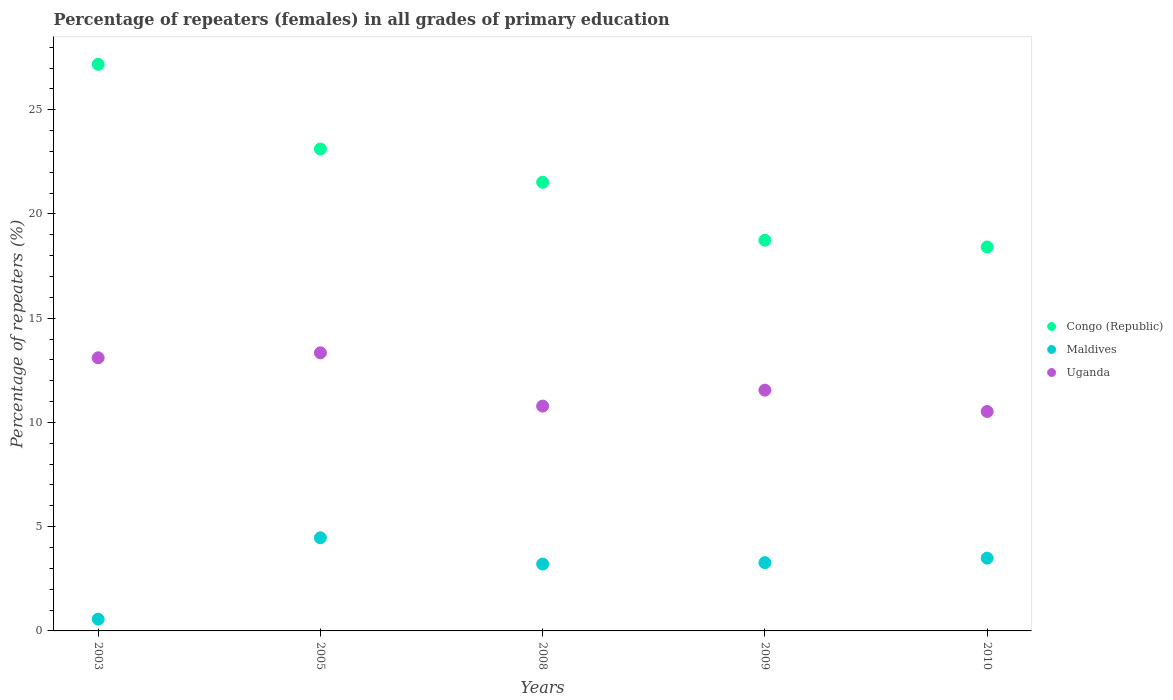How many different coloured dotlines are there?
Ensure brevity in your answer.  3. Is the number of dotlines equal to the number of legend labels?
Offer a very short reply. Yes. What is the percentage of repeaters (females) in Maldives in 2008?
Give a very brief answer. 3.21. Across all years, what is the maximum percentage of repeaters (females) in Uganda?
Provide a short and direct response. 13.34. Across all years, what is the minimum percentage of repeaters (females) in Maldives?
Provide a succinct answer. 0.56. In which year was the percentage of repeaters (females) in Congo (Republic) maximum?
Provide a succinct answer. 2003. What is the total percentage of repeaters (females) in Maldives in the graph?
Ensure brevity in your answer.  15. What is the difference between the percentage of repeaters (females) in Maldives in 2003 and that in 2010?
Ensure brevity in your answer.  -2.93. What is the difference between the percentage of repeaters (females) in Congo (Republic) in 2010 and the percentage of repeaters (females) in Maldives in 2009?
Make the answer very short. 15.14. What is the average percentage of repeaters (females) in Uganda per year?
Your answer should be very brief. 11.86. In the year 2009, what is the difference between the percentage of repeaters (females) in Uganda and percentage of repeaters (females) in Maldives?
Keep it short and to the point. 8.27. In how many years, is the percentage of repeaters (females) in Congo (Republic) greater than 22 %?
Your response must be concise. 2. What is the ratio of the percentage of repeaters (females) in Maldives in 2005 to that in 2008?
Ensure brevity in your answer.  1.39. Is the percentage of repeaters (females) in Uganda in 2009 less than that in 2010?
Keep it short and to the point. No. Is the difference between the percentage of repeaters (females) in Uganda in 2003 and 2009 greater than the difference between the percentage of repeaters (females) in Maldives in 2003 and 2009?
Make the answer very short. Yes. What is the difference between the highest and the second highest percentage of repeaters (females) in Uganda?
Ensure brevity in your answer.  0.24. What is the difference between the highest and the lowest percentage of repeaters (females) in Maldives?
Offer a terse response. 3.9. How many dotlines are there?
Your answer should be compact. 3. Does the graph contain grids?
Offer a terse response. No. Where does the legend appear in the graph?
Provide a short and direct response. Center right. What is the title of the graph?
Keep it short and to the point. Percentage of repeaters (females) in all grades of primary education. What is the label or title of the X-axis?
Make the answer very short. Years. What is the label or title of the Y-axis?
Your answer should be compact. Percentage of repeaters (%). What is the Percentage of repeaters (%) of Congo (Republic) in 2003?
Offer a very short reply. 27.18. What is the Percentage of repeaters (%) of Maldives in 2003?
Offer a very short reply. 0.56. What is the Percentage of repeaters (%) of Uganda in 2003?
Make the answer very short. 13.1. What is the Percentage of repeaters (%) in Congo (Republic) in 2005?
Ensure brevity in your answer.  23.12. What is the Percentage of repeaters (%) of Maldives in 2005?
Provide a succinct answer. 4.47. What is the Percentage of repeaters (%) of Uganda in 2005?
Provide a succinct answer. 13.34. What is the Percentage of repeaters (%) of Congo (Republic) in 2008?
Provide a succinct answer. 21.52. What is the Percentage of repeaters (%) of Maldives in 2008?
Your response must be concise. 3.21. What is the Percentage of repeaters (%) of Uganda in 2008?
Provide a succinct answer. 10.78. What is the Percentage of repeaters (%) of Congo (Republic) in 2009?
Give a very brief answer. 18.74. What is the Percentage of repeaters (%) of Maldives in 2009?
Offer a terse response. 3.27. What is the Percentage of repeaters (%) in Uganda in 2009?
Provide a succinct answer. 11.55. What is the Percentage of repeaters (%) of Congo (Republic) in 2010?
Provide a succinct answer. 18.42. What is the Percentage of repeaters (%) of Maldives in 2010?
Ensure brevity in your answer.  3.49. What is the Percentage of repeaters (%) in Uganda in 2010?
Offer a terse response. 10.53. Across all years, what is the maximum Percentage of repeaters (%) of Congo (Republic)?
Provide a succinct answer. 27.18. Across all years, what is the maximum Percentage of repeaters (%) in Maldives?
Offer a very short reply. 4.47. Across all years, what is the maximum Percentage of repeaters (%) in Uganda?
Keep it short and to the point. 13.34. Across all years, what is the minimum Percentage of repeaters (%) in Congo (Republic)?
Your response must be concise. 18.42. Across all years, what is the minimum Percentage of repeaters (%) in Maldives?
Make the answer very short. 0.56. Across all years, what is the minimum Percentage of repeaters (%) in Uganda?
Make the answer very short. 10.53. What is the total Percentage of repeaters (%) in Congo (Republic) in the graph?
Your answer should be compact. 108.98. What is the total Percentage of repeaters (%) in Maldives in the graph?
Offer a very short reply. 15. What is the total Percentage of repeaters (%) of Uganda in the graph?
Make the answer very short. 59.3. What is the difference between the Percentage of repeaters (%) in Congo (Republic) in 2003 and that in 2005?
Make the answer very short. 4.06. What is the difference between the Percentage of repeaters (%) in Maldives in 2003 and that in 2005?
Give a very brief answer. -3.9. What is the difference between the Percentage of repeaters (%) in Uganda in 2003 and that in 2005?
Offer a terse response. -0.24. What is the difference between the Percentage of repeaters (%) in Congo (Republic) in 2003 and that in 2008?
Your answer should be compact. 5.66. What is the difference between the Percentage of repeaters (%) of Maldives in 2003 and that in 2008?
Provide a succinct answer. -2.64. What is the difference between the Percentage of repeaters (%) in Uganda in 2003 and that in 2008?
Offer a terse response. 2.32. What is the difference between the Percentage of repeaters (%) of Congo (Republic) in 2003 and that in 2009?
Ensure brevity in your answer.  8.44. What is the difference between the Percentage of repeaters (%) in Maldives in 2003 and that in 2009?
Offer a terse response. -2.71. What is the difference between the Percentage of repeaters (%) of Uganda in 2003 and that in 2009?
Give a very brief answer. 1.55. What is the difference between the Percentage of repeaters (%) in Congo (Republic) in 2003 and that in 2010?
Provide a succinct answer. 8.76. What is the difference between the Percentage of repeaters (%) of Maldives in 2003 and that in 2010?
Keep it short and to the point. -2.93. What is the difference between the Percentage of repeaters (%) of Uganda in 2003 and that in 2010?
Your answer should be very brief. 2.58. What is the difference between the Percentage of repeaters (%) of Congo (Republic) in 2005 and that in 2008?
Provide a short and direct response. 1.59. What is the difference between the Percentage of repeaters (%) of Maldives in 2005 and that in 2008?
Your answer should be very brief. 1.26. What is the difference between the Percentage of repeaters (%) in Uganda in 2005 and that in 2008?
Ensure brevity in your answer.  2.56. What is the difference between the Percentage of repeaters (%) of Congo (Republic) in 2005 and that in 2009?
Give a very brief answer. 4.37. What is the difference between the Percentage of repeaters (%) in Maldives in 2005 and that in 2009?
Keep it short and to the point. 1.19. What is the difference between the Percentage of repeaters (%) in Uganda in 2005 and that in 2009?
Your answer should be very brief. 1.79. What is the difference between the Percentage of repeaters (%) of Congo (Republic) in 2005 and that in 2010?
Provide a succinct answer. 4.7. What is the difference between the Percentage of repeaters (%) of Maldives in 2005 and that in 2010?
Make the answer very short. 0.98. What is the difference between the Percentage of repeaters (%) of Uganda in 2005 and that in 2010?
Your response must be concise. 2.81. What is the difference between the Percentage of repeaters (%) in Congo (Republic) in 2008 and that in 2009?
Keep it short and to the point. 2.78. What is the difference between the Percentage of repeaters (%) in Maldives in 2008 and that in 2009?
Ensure brevity in your answer.  -0.07. What is the difference between the Percentage of repeaters (%) in Uganda in 2008 and that in 2009?
Your response must be concise. -0.76. What is the difference between the Percentage of repeaters (%) of Congo (Republic) in 2008 and that in 2010?
Provide a succinct answer. 3.1. What is the difference between the Percentage of repeaters (%) in Maldives in 2008 and that in 2010?
Keep it short and to the point. -0.28. What is the difference between the Percentage of repeaters (%) of Uganda in 2008 and that in 2010?
Provide a short and direct response. 0.26. What is the difference between the Percentage of repeaters (%) in Congo (Republic) in 2009 and that in 2010?
Your answer should be compact. 0.32. What is the difference between the Percentage of repeaters (%) of Maldives in 2009 and that in 2010?
Keep it short and to the point. -0.22. What is the difference between the Percentage of repeaters (%) of Uganda in 2009 and that in 2010?
Your answer should be compact. 1.02. What is the difference between the Percentage of repeaters (%) in Congo (Republic) in 2003 and the Percentage of repeaters (%) in Maldives in 2005?
Provide a succinct answer. 22.71. What is the difference between the Percentage of repeaters (%) in Congo (Republic) in 2003 and the Percentage of repeaters (%) in Uganda in 2005?
Give a very brief answer. 13.84. What is the difference between the Percentage of repeaters (%) in Maldives in 2003 and the Percentage of repeaters (%) in Uganda in 2005?
Keep it short and to the point. -12.78. What is the difference between the Percentage of repeaters (%) of Congo (Republic) in 2003 and the Percentage of repeaters (%) of Maldives in 2008?
Offer a terse response. 23.97. What is the difference between the Percentage of repeaters (%) of Congo (Republic) in 2003 and the Percentage of repeaters (%) of Uganda in 2008?
Ensure brevity in your answer.  16.39. What is the difference between the Percentage of repeaters (%) of Maldives in 2003 and the Percentage of repeaters (%) of Uganda in 2008?
Offer a very short reply. -10.22. What is the difference between the Percentage of repeaters (%) in Congo (Republic) in 2003 and the Percentage of repeaters (%) in Maldives in 2009?
Your answer should be very brief. 23.9. What is the difference between the Percentage of repeaters (%) in Congo (Republic) in 2003 and the Percentage of repeaters (%) in Uganda in 2009?
Provide a succinct answer. 15.63. What is the difference between the Percentage of repeaters (%) in Maldives in 2003 and the Percentage of repeaters (%) in Uganda in 2009?
Provide a succinct answer. -10.99. What is the difference between the Percentage of repeaters (%) in Congo (Republic) in 2003 and the Percentage of repeaters (%) in Maldives in 2010?
Keep it short and to the point. 23.69. What is the difference between the Percentage of repeaters (%) of Congo (Republic) in 2003 and the Percentage of repeaters (%) of Uganda in 2010?
Your answer should be very brief. 16.65. What is the difference between the Percentage of repeaters (%) of Maldives in 2003 and the Percentage of repeaters (%) of Uganda in 2010?
Give a very brief answer. -9.96. What is the difference between the Percentage of repeaters (%) in Congo (Republic) in 2005 and the Percentage of repeaters (%) in Maldives in 2008?
Your answer should be very brief. 19.91. What is the difference between the Percentage of repeaters (%) of Congo (Republic) in 2005 and the Percentage of repeaters (%) of Uganda in 2008?
Ensure brevity in your answer.  12.33. What is the difference between the Percentage of repeaters (%) in Maldives in 2005 and the Percentage of repeaters (%) in Uganda in 2008?
Provide a short and direct response. -6.32. What is the difference between the Percentage of repeaters (%) in Congo (Republic) in 2005 and the Percentage of repeaters (%) in Maldives in 2009?
Offer a terse response. 19.84. What is the difference between the Percentage of repeaters (%) of Congo (Republic) in 2005 and the Percentage of repeaters (%) of Uganda in 2009?
Your answer should be compact. 11.57. What is the difference between the Percentage of repeaters (%) in Maldives in 2005 and the Percentage of repeaters (%) in Uganda in 2009?
Provide a short and direct response. -7.08. What is the difference between the Percentage of repeaters (%) of Congo (Republic) in 2005 and the Percentage of repeaters (%) of Maldives in 2010?
Your response must be concise. 19.63. What is the difference between the Percentage of repeaters (%) in Congo (Republic) in 2005 and the Percentage of repeaters (%) in Uganda in 2010?
Ensure brevity in your answer.  12.59. What is the difference between the Percentage of repeaters (%) of Maldives in 2005 and the Percentage of repeaters (%) of Uganda in 2010?
Your answer should be very brief. -6.06. What is the difference between the Percentage of repeaters (%) in Congo (Republic) in 2008 and the Percentage of repeaters (%) in Maldives in 2009?
Keep it short and to the point. 18.25. What is the difference between the Percentage of repeaters (%) in Congo (Republic) in 2008 and the Percentage of repeaters (%) in Uganda in 2009?
Offer a terse response. 9.97. What is the difference between the Percentage of repeaters (%) in Maldives in 2008 and the Percentage of repeaters (%) in Uganda in 2009?
Make the answer very short. -8.34. What is the difference between the Percentage of repeaters (%) in Congo (Republic) in 2008 and the Percentage of repeaters (%) in Maldives in 2010?
Your answer should be compact. 18.03. What is the difference between the Percentage of repeaters (%) of Congo (Republic) in 2008 and the Percentage of repeaters (%) of Uganda in 2010?
Keep it short and to the point. 11. What is the difference between the Percentage of repeaters (%) in Maldives in 2008 and the Percentage of repeaters (%) in Uganda in 2010?
Ensure brevity in your answer.  -7.32. What is the difference between the Percentage of repeaters (%) in Congo (Republic) in 2009 and the Percentage of repeaters (%) in Maldives in 2010?
Offer a very short reply. 15.25. What is the difference between the Percentage of repeaters (%) of Congo (Republic) in 2009 and the Percentage of repeaters (%) of Uganda in 2010?
Offer a very short reply. 8.22. What is the difference between the Percentage of repeaters (%) in Maldives in 2009 and the Percentage of repeaters (%) in Uganda in 2010?
Make the answer very short. -7.25. What is the average Percentage of repeaters (%) in Congo (Republic) per year?
Your response must be concise. 21.8. What is the average Percentage of repeaters (%) in Maldives per year?
Ensure brevity in your answer.  3. What is the average Percentage of repeaters (%) in Uganda per year?
Offer a very short reply. 11.86. In the year 2003, what is the difference between the Percentage of repeaters (%) in Congo (Republic) and Percentage of repeaters (%) in Maldives?
Offer a very short reply. 26.62. In the year 2003, what is the difference between the Percentage of repeaters (%) of Congo (Republic) and Percentage of repeaters (%) of Uganda?
Your response must be concise. 14.08. In the year 2003, what is the difference between the Percentage of repeaters (%) of Maldives and Percentage of repeaters (%) of Uganda?
Make the answer very short. -12.54. In the year 2005, what is the difference between the Percentage of repeaters (%) in Congo (Republic) and Percentage of repeaters (%) in Maldives?
Ensure brevity in your answer.  18.65. In the year 2005, what is the difference between the Percentage of repeaters (%) of Congo (Republic) and Percentage of repeaters (%) of Uganda?
Give a very brief answer. 9.78. In the year 2005, what is the difference between the Percentage of repeaters (%) of Maldives and Percentage of repeaters (%) of Uganda?
Offer a very short reply. -8.87. In the year 2008, what is the difference between the Percentage of repeaters (%) of Congo (Republic) and Percentage of repeaters (%) of Maldives?
Give a very brief answer. 18.32. In the year 2008, what is the difference between the Percentage of repeaters (%) of Congo (Republic) and Percentage of repeaters (%) of Uganda?
Your answer should be compact. 10.74. In the year 2008, what is the difference between the Percentage of repeaters (%) in Maldives and Percentage of repeaters (%) in Uganda?
Your answer should be compact. -7.58. In the year 2009, what is the difference between the Percentage of repeaters (%) in Congo (Republic) and Percentage of repeaters (%) in Maldives?
Offer a very short reply. 15.47. In the year 2009, what is the difference between the Percentage of repeaters (%) of Congo (Republic) and Percentage of repeaters (%) of Uganda?
Provide a succinct answer. 7.19. In the year 2009, what is the difference between the Percentage of repeaters (%) in Maldives and Percentage of repeaters (%) in Uganda?
Your response must be concise. -8.27. In the year 2010, what is the difference between the Percentage of repeaters (%) of Congo (Republic) and Percentage of repeaters (%) of Maldives?
Offer a very short reply. 14.93. In the year 2010, what is the difference between the Percentage of repeaters (%) in Congo (Republic) and Percentage of repeaters (%) in Uganda?
Keep it short and to the point. 7.89. In the year 2010, what is the difference between the Percentage of repeaters (%) in Maldives and Percentage of repeaters (%) in Uganda?
Your response must be concise. -7.04. What is the ratio of the Percentage of repeaters (%) in Congo (Republic) in 2003 to that in 2005?
Ensure brevity in your answer.  1.18. What is the ratio of the Percentage of repeaters (%) in Maldives in 2003 to that in 2005?
Your answer should be compact. 0.13. What is the ratio of the Percentage of repeaters (%) of Uganda in 2003 to that in 2005?
Provide a short and direct response. 0.98. What is the ratio of the Percentage of repeaters (%) in Congo (Republic) in 2003 to that in 2008?
Offer a very short reply. 1.26. What is the ratio of the Percentage of repeaters (%) in Maldives in 2003 to that in 2008?
Give a very brief answer. 0.18. What is the ratio of the Percentage of repeaters (%) of Uganda in 2003 to that in 2008?
Your answer should be very brief. 1.21. What is the ratio of the Percentage of repeaters (%) of Congo (Republic) in 2003 to that in 2009?
Offer a terse response. 1.45. What is the ratio of the Percentage of repeaters (%) in Maldives in 2003 to that in 2009?
Provide a succinct answer. 0.17. What is the ratio of the Percentage of repeaters (%) in Uganda in 2003 to that in 2009?
Give a very brief answer. 1.13. What is the ratio of the Percentage of repeaters (%) in Congo (Republic) in 2003 to that in 2010?
Make the answer very short. 1.48. What is the ratio of the Percentage of repeaters (%) of Maldives in 2003 to that in 2010?
Offer a very short reply. 0.16. What is the ratio of the Percentage of repeaters (%) of Uganda in 2003 to that in 2010?
Offer a very short reply. 1.24. What is the ratio of the Percentage of repeaters (%) in Congo (Republic) in 2005 to that in 2008?
Make the answer very short. 1.07. What is the ratio of the Percentage of repeaters (%) of Maldives in 2005 to that in 2008?
Your answer should be compact. 1.39. What is the ratio of the Percentage of repeaters (%) of Uganda in 2005 to that in 2008?
Keep it short and to the point. 1.24. What is the ratio of the Percentage of repeaters (%) in Congo (Republic) in 2005 to that in 2009?
Keep it short and to the point. 1.23. What is the ratio of the Percentage of repeaters (%) in Maldives in 2005 to that in 2009?
Ensure brevity in your answer.  1.36. What is the ratio of the Percentage of repeaters (%) in Uganda in 2005 to that in 2009?
Your answer should be compact. 1.16. What is the ratio of the Percentage of repeaters (%) in Congo (Republic) in 2005 to that in 2010?
Provide a succinct answer. 1.25. What is the ratio of the Percentage of repeaters (%) of Maldives in 2005 to that in 2010?
Your answer should be compact. 1.28. What is the ratio of the Percentage of repeaters (%) in Uganda in 2005 to that in 2010?
Your answer should be very brief. 1.27. What is the ratio of the Percentage of repeaters (%) of Congo (Republic) in 2008 to that in 2009?
Ensure brevity in your answer.  1.15. What is the ratio of the Percentage of repeaters (%) of Maldives in 2008 to that in 2009?
Give a very brief answer. 0.98. What is the ratio of the Percentage of repeaters (%) of Uganda in 2008 to that in 2009?
Give a very brief answer. 0.93. What is the ratio of the Percentage of repeaters (%) in Congo (Republic) in 2008 to that in 2010?
Your answer should be very brief. 1.17. What is the ratio of the Percentage of repeaters (%) in Maldives in 2008 to that in 2010?
Offer a terse response. 0.92. What is the ratio of the Percentage of repeaters (%) of Uganda in 2008 to that in 2010?
Your response must be concise. 1.02. What is the ratio of the Percentage of repeaters (%) of Congo (Republic) in 2009 to that in 2010?
Keep it short and to the point. 1.02. What is the ratio of the Percentage of repeaters (%) of Maldives in 2009 to that in 2010?
Your response must be concise. 0.94. What is the ratio of the Percentage of repeaters (%) in Uganda in 2009 to that in 2010?
Provide a short and direct response. 1.1. What is the difference between the highest and the second highest Percentage of repeaters (%) in Congo (Republic)?
Offer a very short reply. 4.06. What is the difference between the highest and the second highest Percentage of repeaters (%) of Maldives?
Provide a succinct answer. 0.98. What is the difference between the highest and the second highest Percentage of repeaters (%) of Uganda?
Ensure brevity in your answer.  0.24. What is the difference between the highest and the lowest Percentage of repeaters (%) in Congo (Republic)?
Provide a succinct answer. 8.76. What is the difference between the highest and the lowest Percentage of repeaters (%) of Maldives?
Give a very brief answer. 3.9. What is the difference between the highest and the lowest Percentage of repeaters (%) in Uganda?
Give a very brief answer. 2.81. 